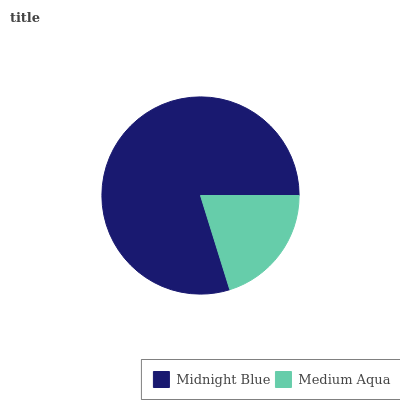Is Medium Aqua the minimum?
Answer yes or no. Yes. Is Midnight Blue the maximum?
Answer yes or no. Yes. Is Medium Aqua the maximum?
Answer yes or no. No. Is Midnight Blue greater than Medium Aqua?
Answer yes or no. Yes. Is Medium Aqua less than Midnight Blue?
Answer yes or no. Yes. Is Medium Aqua greater than Midnight Blue?
Answer yes or no. No. Is Midnight Blue less than Medium Aqua?
Answer yes or no. No. Is Midnight Blue the high median?
Answer yes or no. Yes. Is Medium Aqua the low median?
Answer yes or no. Yes. Is Medium Aqua the high median?
Answer yes or no. No. Is Midnight Blue the low median?
Answer yes or no. No. 